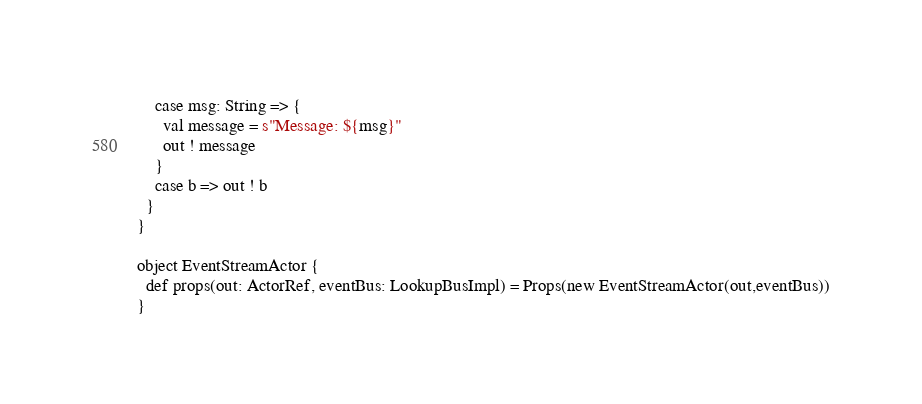<code> <loc_0><loc_0><loc_500><loc_500><_Scala_>    case msg: String => {
      val message = s"Message: ${msg}"
      out ! message
    }
    case b => out ! b
  }
}

object EventStreamActor {
  def props(out: ActorRef, eventBus: LookupBusImpl) = Props(new EventStreamActor(out,eventBus))
}
</code> 